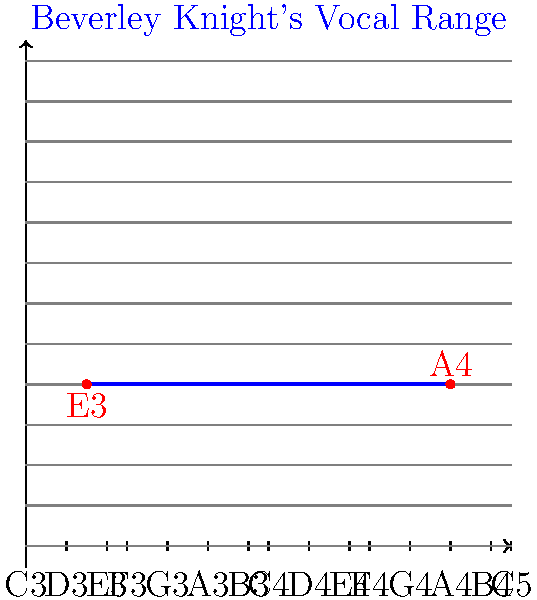On the musical staff coordinate system shown above, Beverley Knight's vocal range is represented by the blue line. What is the approximate range of her voice in musical notes? To determine Beverley Knight's vocal range from the given coordinate system, we need to follow these steps:

1. Identify the lower bound of her range:
   - The blue line starts at the red dot labeled "E3"
   - This corresponds to the note E3 on the vertical axis

2. Identify the upper bound of her range:
   - The blue line ends at the red dot labeled "A4"
   - This corresponds to the note A4 on the vertical axis

3. Calculate the range:
   - The range is from E3 to A4
   - This covers 3 octaves and a perfect fourth (A is 4 semitones above E)

4. Express the range in musical notation:
   - In classical music notation, this would be written as E3-A4

Therefore, based on the coordinate system provided, Beverley Knight's approximate vocal range spans from E3 to A4.
Answer: E3-A4 